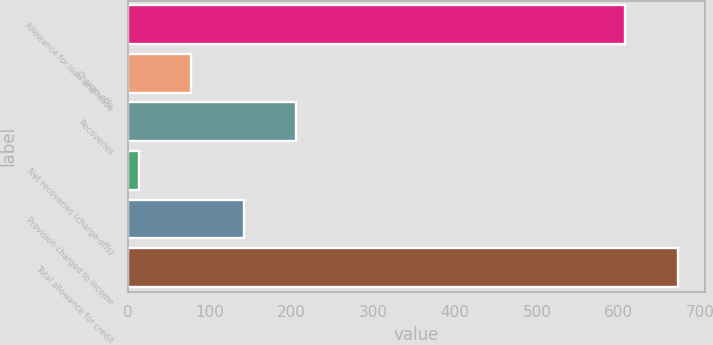Convert chart. <chart><loc_0><loc_0><loc_500><loc_500><bar_chart><fcel>Allowance for loan and lease<fcel>Charge-offs<fcel>Recoveries<fcel>Net recoveries (charge-offs)<fcel>Provision charged to income<fcel>Total allowance for credit<nl><fcel>608.1<fcel>77.1<fcel>205.3<fcel>13<fcel>141.2<fcel>672.2<nl></chart> 